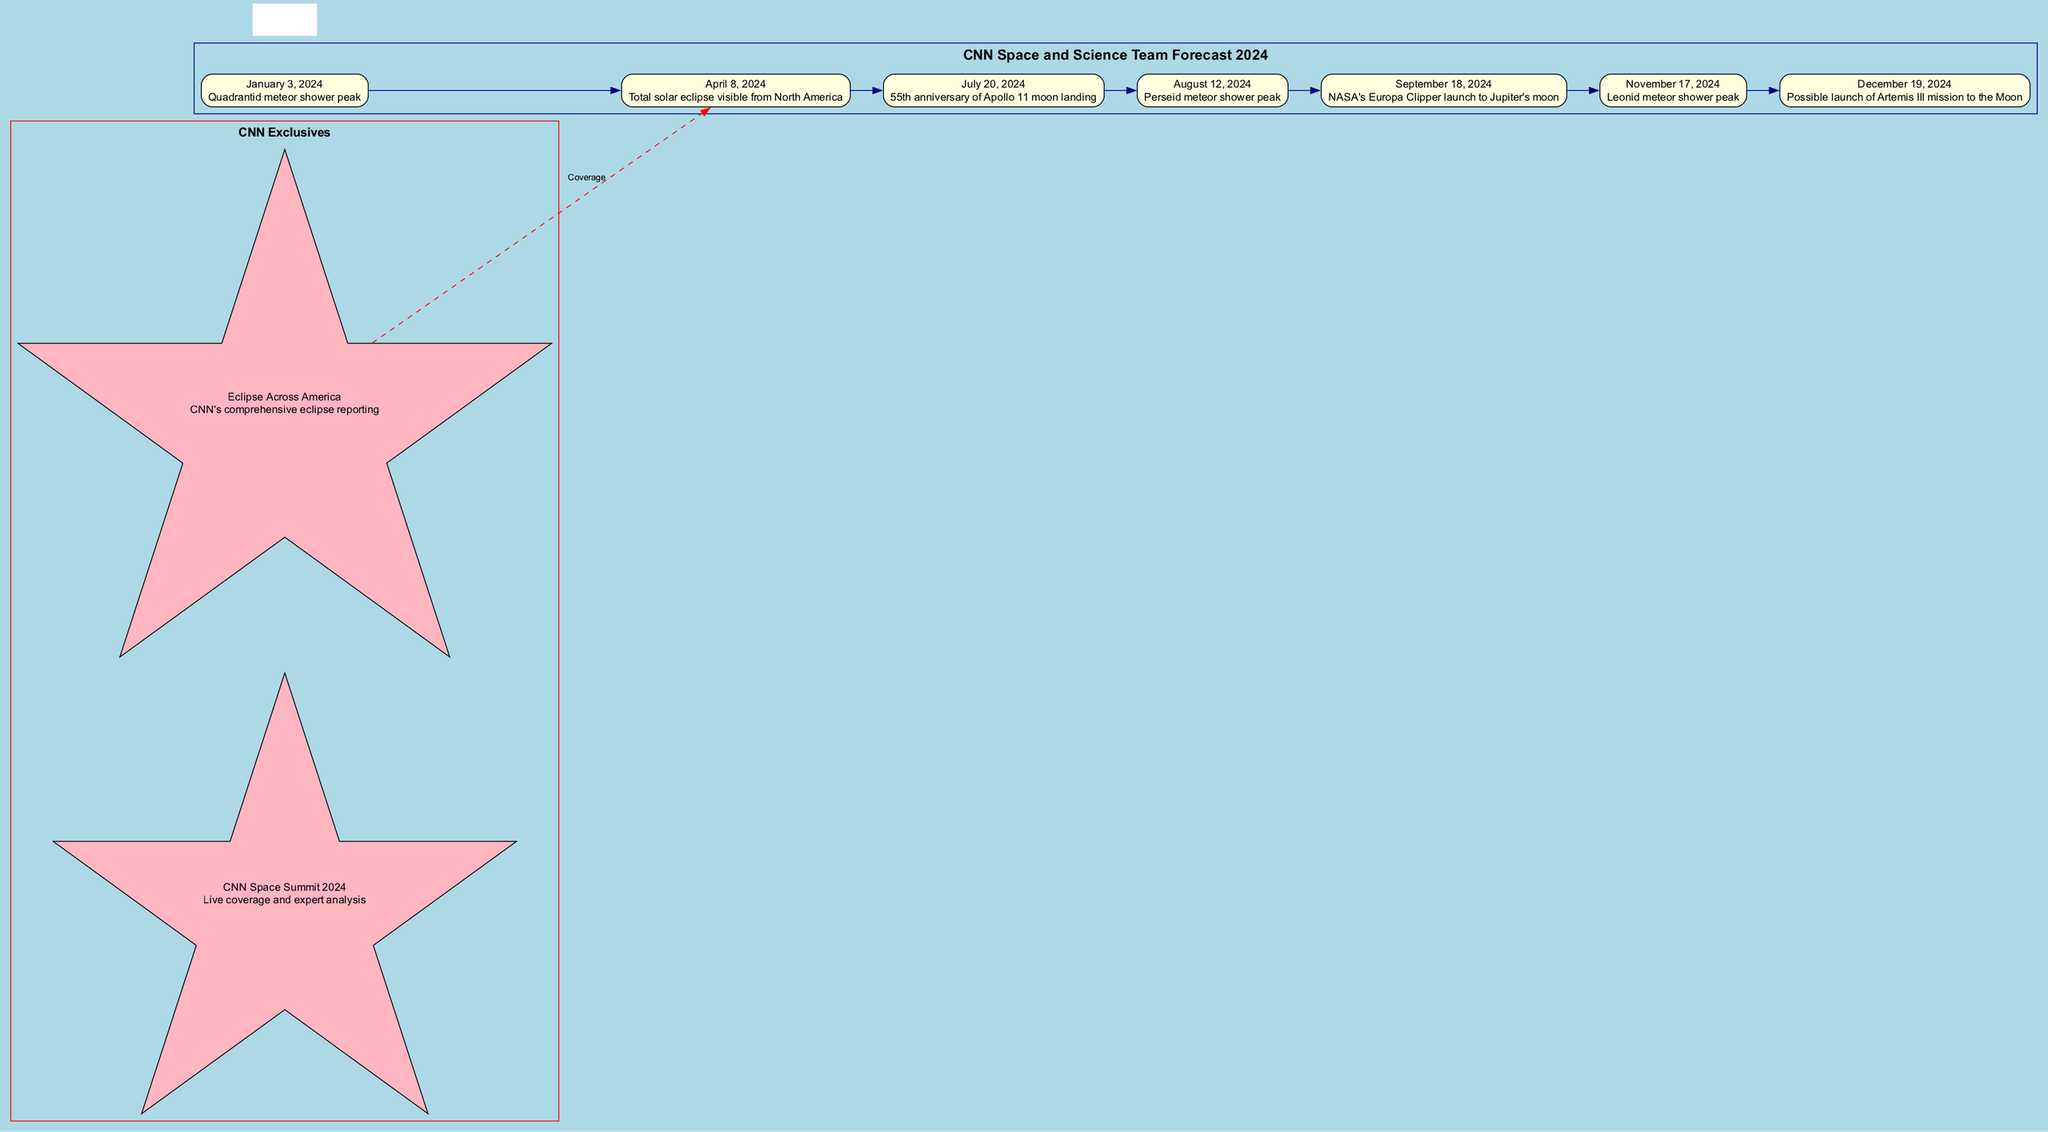What event occurs on April 8, 2024? The diagram shows a node for the date April 8, 2024, with the event described as a "Total solar eclipse visible from North America."
Answer: Total solar eclipse visible from North America How many major astronomical events are listed in the timeline? By counting the nodes representing the events in the diagram, we can see there are seven distinct dates with events.
Answer: 7 What is the event on July 20, 2024? The node for July 20, 2024, states the event is the "55th anniversary of Apollo 11 moon landing."
Answer: 55th anniversary of Apollo 11 moon landing Which event is followed by the Leonid meteor shower peak? The diagram indicates that the Leonid meteor shower peak on November 17, 2024, follows the event of the NASA's Europa Clipper launch on September 18, 2024.
Answer: NASA's Europa Clipper launch What special CNN coverage is linked to the total solar eclipse event? The diagram connects "Eclipse Across America" as the special CNN coverage related to the total solar eclipse event on April 8, 2024.
Answer: Eclipse Across America What color are the nodes for the major events? All nodes representing the major astronomical events are filled with light yellow color in the diagram.
Answer: Light yellow Which event is anticipated to possibly launch Artemis III mission to the Moon? According to the diagram, the possible launch of Artemis III mission to the Moon is indicated for December 19, 2024.
Answer: Possible launch of Artemis III mission to the Moon What was the first event on the timeline? The first event listed in the timeline is the "Quadrantid meteor shower peak" occurring on January 3, 2024.
Answer: Quadrantid meteor shower peak How is CNN connected to the major events in the diagram? The diagram illustrates connections via edges, specifically showing one dashed edge linking "Eclipse Across America" to the "Total solar eclipse visible from North America" event.
Answer: Through dashed edges connecting exclusives to specific events 